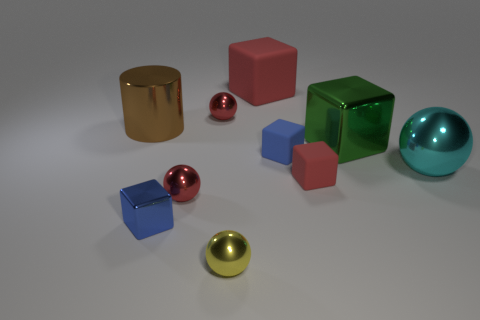Can you explain the different materials present in the scene? Certainly! The objects displayed in the scene appear to be made of various materials that give them distinct finishes. The golden cylinder and the silver sphere, for example, have reflective metallic surfaces suggesting they are made of metal. The cube in the center has a glass-like texture, indicating it could be made of transparent acrylic or glass. Lastly, the solid-colored objects with a matte finish resemble opaque plastics. 